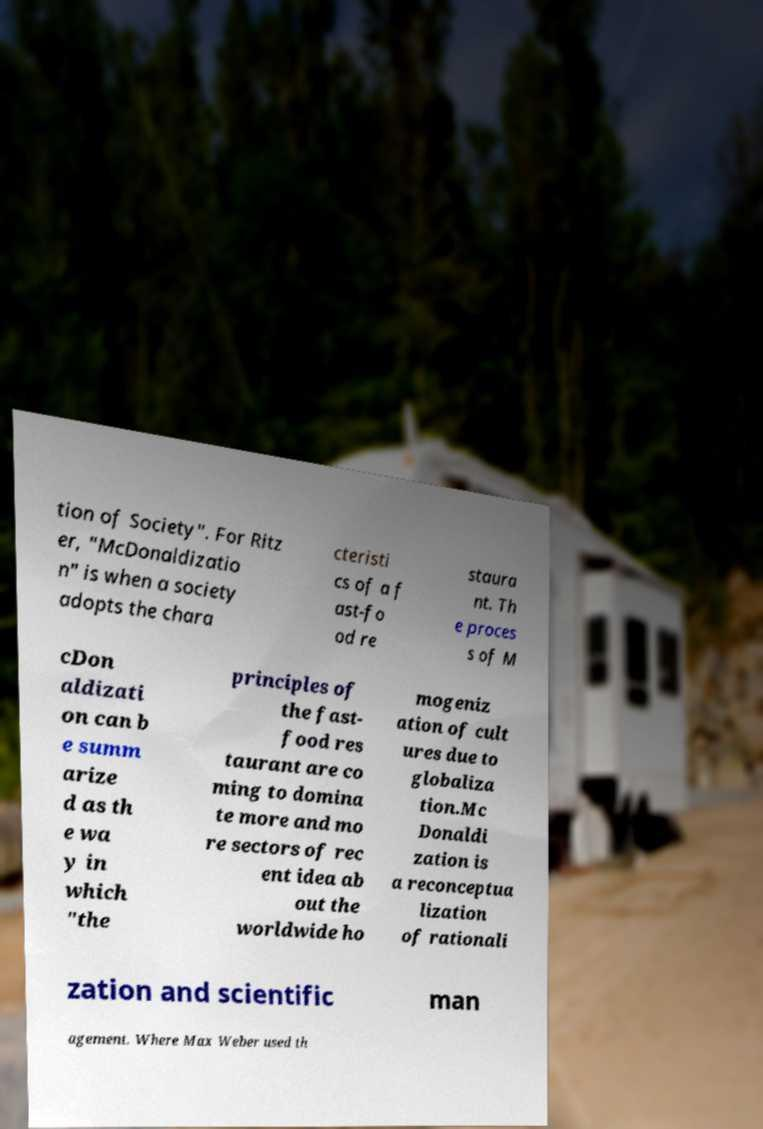Can you accurately transcribe the text from the provided image for me? tion of Society". For Ritz er, "McDonaldizatio n" is when a society adopts the chara cteristi cs of a f ast-fo od re staura nt. Th e proces s of M cDon aldizati on can b e summ arize d as th e wa y in which "the principles of the fast- food res taurant are co ming to domina te more and mo re sectors of rec ent idea ab out the worldwide ho mogeniz ation of cult ures due to globaliza tion.Mc Donaldi zation is a reconceptua lization of rationali zation and scientific man agement. Where Max Weber used th 